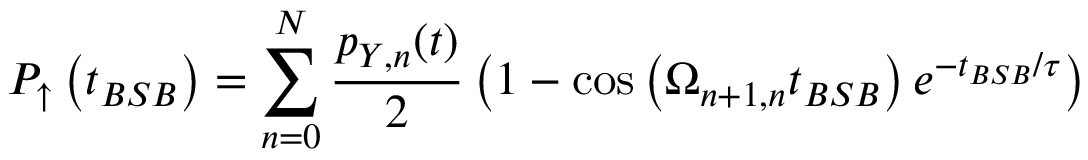Convert formula to latex. <formula><loc_0><loc_0><loc_500><loc_500>P _ { \uparrow } \left ( t _ { B S B } \right ) = \sum _ { n = 0 } ^ { N } { \frac { p _ { Y , n } ( t ) } { 2 } \left ( 1 - \cos \left ( \Omega _ { n + 1 , n } t _ { B S B } \right ) e ^ { - t _ { B S B } / \tau } \right ) }</formula> 